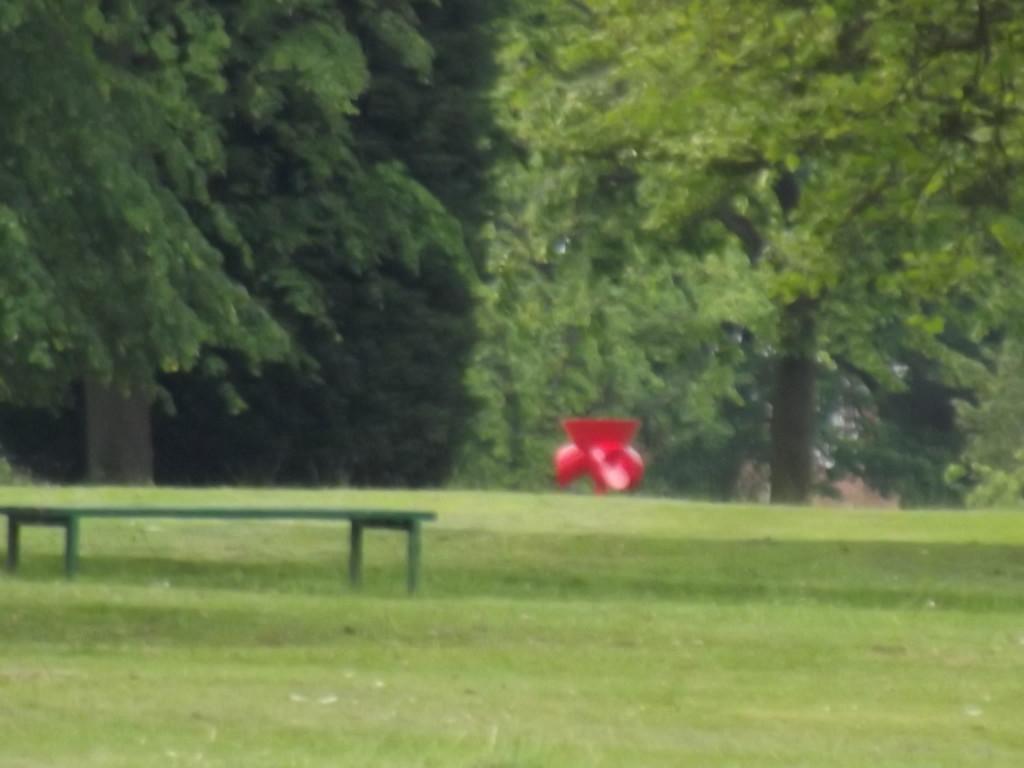In one or two sentences, can you explain what this image depicts? In this image there is a bench on the surface of the grass and there is an object in red color. In the background there are trees. 